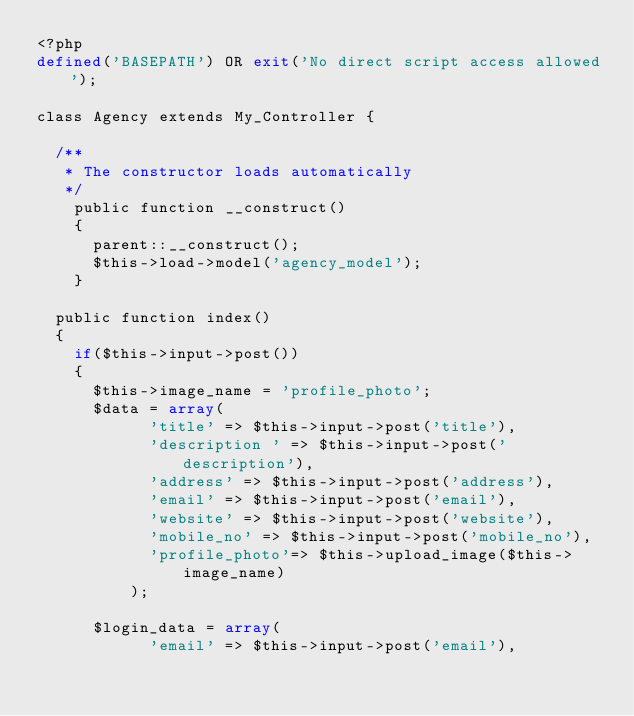<code> <loc_0><loc_0><loc_500><loc_500><_PHP_><?php
defined('BASEPATH') OR exit('No direct script access allowed');

class Agency extends My_Controller {

	/**
	 * The constructor loads automatically
	 */
    public function __construct()
    {
    	parent::__construct();
    	$this->load->model('agency_model');
    }

	public function index()
	{
		if($this->input->post())
		{
			$this->image_name = 'profile_photo';
			$data = array(
						'title' => $this->input->post('title'),
						'description ' => $this->input->post('description'),
						'address' => $this->input->post('address'),
						'email' => $this->input->post('email'),
						'website' => $this->input->post('website'),
						'mobile_no' => $this->input->post('mobile_no'),
						'profile_photo'=> $this->upload_image($this->image_name)
					);

			$login_data = array(
						'email' => $this->input->post('email'),</code> 